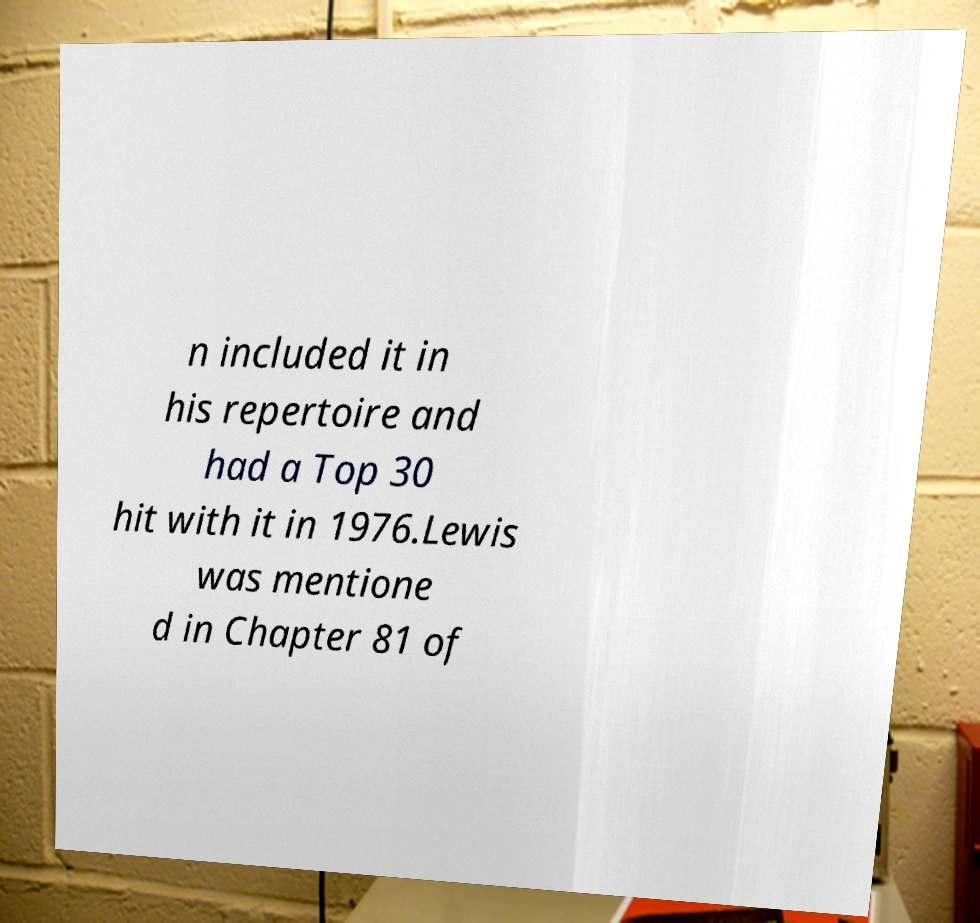Please read and relay the text visible in this image. What does it say? n included it in his repertoire and had a Top 30 hit with it in 1976.Lewis was mentione d in Chapter 81 of 